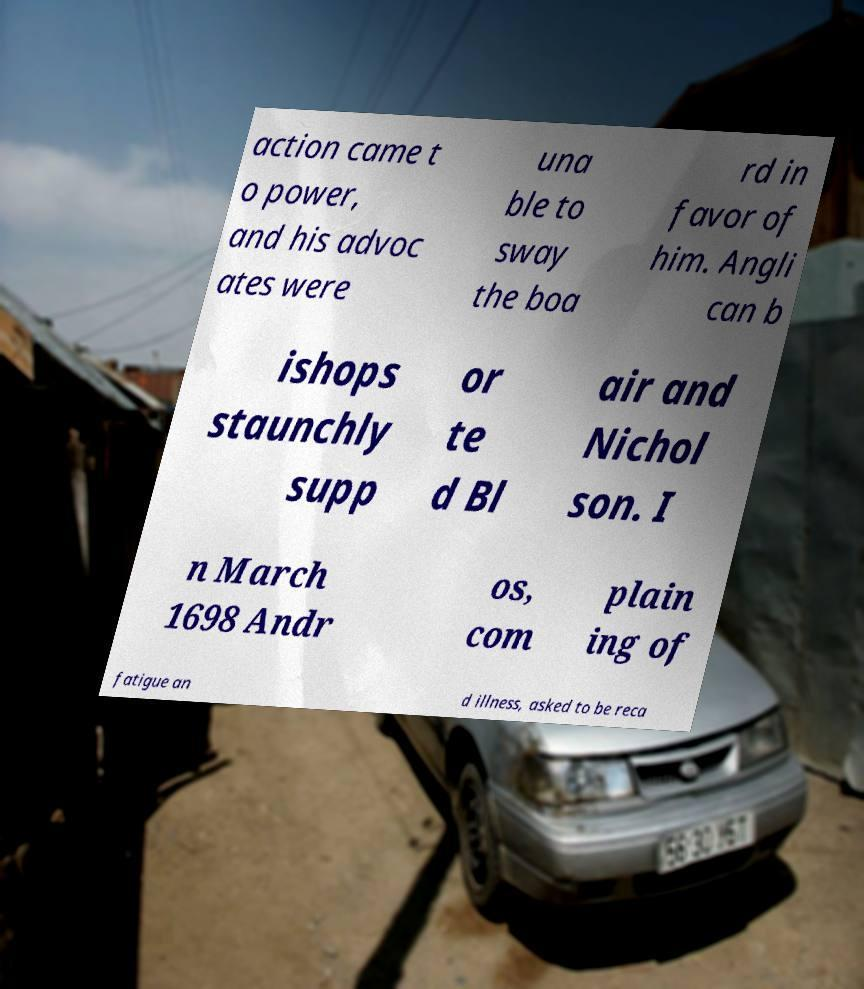Could you extract and type out the text from this image? action came t o power, and his advoc ates were una ble to sway the boa rd in favor of him. Angli can b ishops staunchly supp or te d Bl air and Nichol son. I n March 1698 Andr os, com plain ing of fatigue an d illness, asked to be reca 